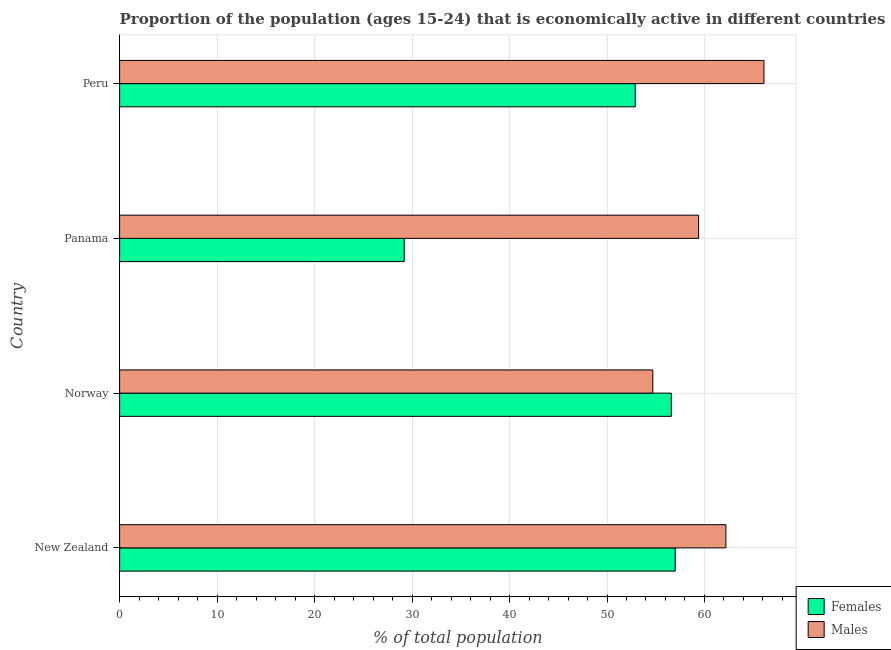How many different coloured bars are there?
Give a very brief answer. 2. What is the label of the 4th group of bars from the top?
Your answer should be very brief. New Zealand. In how many cases, is the number of bars for a given country not equal to the number of legend labels?
Give a very brief answer. 0. What is the percentage of economically active male population in Panama?
Keep it short and to the point. 59.4. Across all countries, what is the maximum percentage of economically active male population?
Your answer should be very brief. 66.1. Across all countries, what is the minimum percentage of economically active male population?
Provide a succinct answer. 54.7. In which country was the percentage of economically active female population minimum?
Your answer should be compact. Panama. What is the total percentage of economically active male population in the graph?
Keep it short and to the point. 242.4. What is the difference between the percentage of economically active female population in Norway and the percentage of economically active male population in New Zealand?
Offer a very short reply. -5.6. What is the average percentage of economically active male population per country?
Provide a short and direct response. 60.6. In how many countries, is the percentage of economically active male population greater than 16 %?
Give a very brief answer. 4. What is the ratio of the percentage of economically active female population in Panama to that in Peru?
Offer a terse response. 0.55. Is the percentage of economically active male population in Norway less than that in Peru?
Keep it short and to the point. Yes. Is the difference between the percentage of economically active male population in Norway and Panama greater than the difference between the percentage of economically active female population in Norway and Panama?
Give a very brief answer. No. What is the difference between the highest and the lowest percentage of economically active female population?
Offer a very short reply. 27.8. In how many countries, is the percentage of economically active male population greater than the average percentage of economically active male population taken over all countries?
Offer a terse response. 2. Is the sum of the percentage of economically active male population in Panama and Peru greater than the maximum percentage of economically active female population across all countries?
Offer a very short reply. Yes. What does the 1st bar from the top in New Zealand represents?
Provide a succinct answer. Males. What does the 1st bar from the bottom in New Zealand represents?
Offer a very short reply. Females. How many countries are there in the graph?
Provide a short and direct response. 4. Are the values on the major ticks of X-axis written in scientific E-notation?
Your answer should be compact. No. Does the graph contain any zero values?
Offer a very short reply. No. Does the graph contain grids?
Provide a succinct answer. Yes. How many legend labels are there?
Offer a very short reply. 2. What is the title of the graph?
Make the answer very short. Proportion of the population (ages 15-24) that is economically active in different countries. Does "Export" appear as one of the legend labels in the graph?
Your answer should be very brief. No. What is the label or title of the X-axis?
Keep it short and to the point. % of total population. What is the % of total population in Females in New Zealand?
Give a very brief answer. 57. What is the % of total population in Males in New Zealand?
Offer a very short reply. 62.2. What is the % of total population of Females in Norway?
Provide a short and direct response. 56.6. What is the % of total population of Males in Norway?
Provide a succinct answer. 54.7. What is the % of total population in Females in Panama?
Your answer should be very brief. 29.2. What is the % of total population of Males in Panama?
Give a very brief answer. 59.4. What is the % of total population of Females in Peru?
Make the answer very short. 52.9. What is the % of total population of Males in Peru?
Offer a terse response. 66.1. Across all countries, what is the maximum % of total population of Females?
Keep it short and to the point. 57. Across all countries, what is the maximum % of total population of Males?
Offer a terse response. 66.1. Across all countries, what is the minimum % of total population of Females?
Keep it short and to the point. 29.2. Across all countries, what is the minimum % of total population of Males?
Your answer should be very brief. 54.7. What is the total % of total population in Females in the graph?
Ensure brevity in your answer.  195.7. What is the total % of total population of Males in the graph?
Offer a very short reply. 242.4. What is the difference between the % of total population in Females in New Zealand and that in Panama?
Your response must be concise. 27.8. What is the difference between the % of total population of Females in New Zealand and that in Peru?
Your answer should be compact. 4.1. What is the difference between the % of total population of Females in Norway and that in Panama?
Offer a very short reply. 27.4. What is the difference between the % of total population in Males in Norway and that in Panama?
Make the answer very short. -4.7. What is the difference between the % of total population of Males in Norway and that in Peru?
Your response must be concise. -11.4. What is the difference between the % of total population of Females in Panama and that in Peru?
Give a very brief answer. -23.7. What is the difference between the % of total population in Females in New Zealand and the % of total population in Males in Panama?
Provide a succinct answer. -2.4. What is the difference between the % of total population in Females in New Zealand and the % of total population in Males in Peru?
Keep it short and to the point. -9.1. What is the difference between the % of total population of Females in Panama and the % of total population of Males in Peru?
Ensure brevity in your answer.  -36.9. What is the average % of total population in Females per country?
Keep it short and to the point. 48.92. What is the average % of total population of Males per country?
Your response must be concise. 60.6. What is the difference between the % of total population in Females and % of total population in Males in Panama?
Your answer should be very brief. -30.2. What is the difference between the % of total population in Females and % of total population in Males in Peru?
Your response must be concise. -13.2. What is the ratio of the % of total population of Females in New Zealand to that in Norway?
Provide a succinct answer. 1.01. What is the ratio of the % of total population in Males in New Zealand to that in Norway?
Your answer should be very brief. 1.14. What is the ratio of the % of total population of Females in New Zealand to that in Panama?
Make the answer very short. 1.95. What is the ratio of the % of total population in Males in New Zealand to that in Panama?
Your answer should be very brief. 1.05. What is the ratio of the % of total population of Females in New Zealand to that in Peru?
Provide a short and direct response. 1.08. What is the ratio of the % of total population in Males in New Zealand to that in Peru?
Ensure brevity in your answer.  0.94. What is the ratio of the % of total population in Females in Norway to that in Panama?
Your response must be concise. 1.94. What is the ratio of the % of total population in Males in Norway to that in Panama?
Offer a very short reply. 0.92. What is the ratio of the % of total population of Females in Norway to that in Peru?
Offer a very short reply. 1.07. What is the ratio of the % of total population of Males in Norway to that in Peru?
Make the answer very short. 0.83. What is the ratio of the % of total population in Females in Panama to that in Peru?
Make the answer very short. 0.55. What is the ratio of the % of total population of Males in Panama to that in Peru?
Your answer should be compact. 0.9. What is the difference between the highest and the second highest % of total population in Males?
Give a very brief answer. 3.9. What is the difference between the highest and the lowest % of total population in Females?
Give a very brief answer. 27.8. 